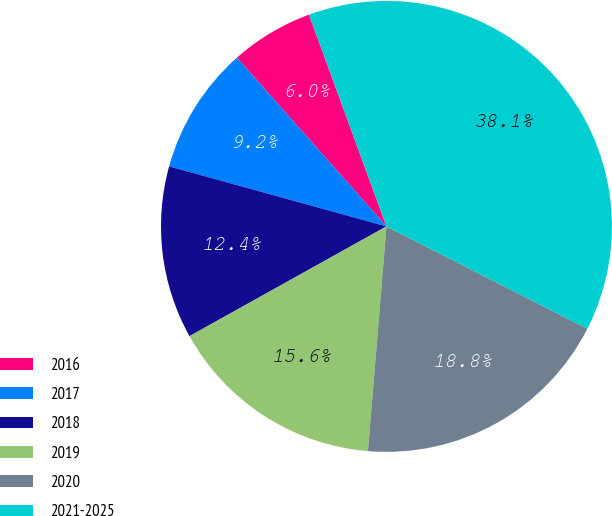<chart> <loc_0><loc_0><loc_500><loc_500><pie_chart><fcel>2016<fcel>2017<fcel>2018<fcel>2019<fcel>2020<fcel>2021-2025<nl><fcel>5.96%<fcel>9.17%<fcel>12.38%<fcel>15.6%<fcel>18.81%<fcel>38.08%<nl></chart> 